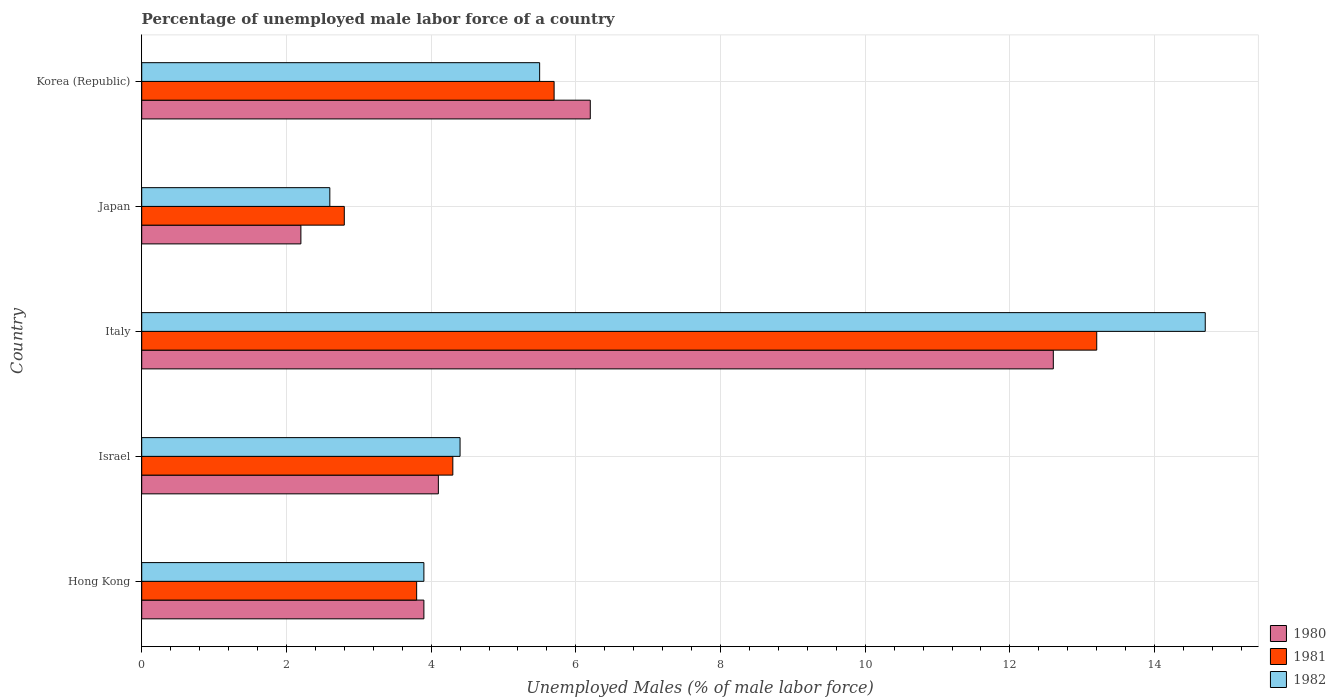How many different coloured bars are there?
Provide a short and direct response. 3. How many groups of bars are there?
Ensure brevity in your answer.  5. How many bars are there on the 3rd tick from the top?
Your answer should be very brief. 3. In how many cases, is the number of bars for a given country not equal to the number of legend labels?
Keep it short and to the point. 0. What is the percentage of unemployed male labor force in 1982 in Japan?
Your answer should be very brief. 2.6. Across all countries, what is the maximum percentage of unemployed male labor force in 1981?
Your answer should be very brief. 13.2. Across all countries, what is the minimum percentage of unemployed male labor force in 1980?
Make the answer very short. 2.2. In which country was the percentage of unemployed male labor force in 1980 maximum?
Ensure brevity in your answer.  Italy. What is the total percentage of unemployed male labor force in 1981 in the graph?
Offer a very short reply. 29.8. What is the difference between the percentage of unemployed male labor force in 1982 in Hong Kong and that in Korea (Republic)?
Keep it short and to the point. -1.6. What is the difference between the percentage of unemployed male labor force in 1981 in Israel and the percentage of unemployed male labor force in 1982 in Hong Kong?
Your response must be concise. 0.4. What is the average percentage of unemployed male labor force in 1982 per country?
Provide a short and direct response. 6.22. What is the difference between the percentage of unemployed male labor force in 1980 and percentage of unemployed male labor force in 1982 in Korea (Republic)?
Make the answer very short. 0.7. In how many countries, is the percentage of unemployed male labor force in 1982 greater than 8 %?
Make the answer very short. 1. What is the ratio of the percentage of unemployed male labor force in 1982 in Japan to that in Korea (Republic)?
Provide a succinct answer. 0.47. Is the percentage of unemployed male labor force in 1980 in Israel less than that in Korea (Republic)?
Offer a very short reply. Yes. What is the difference between the highest and the second highest percentage of unemployed male labor force in 1981?
Provide a short and direct response. 7.5. What is the difference between the highest and the lowest percentage of unemployed male labor force in 1980?
Give a very brief answer. 10.4. In how many countries, is the percentage of unemployed male labor force in 1981 greater than the average percentage of unemployed male labor force in 1981 taken over all countries?
Offer a terse response. 1. What does the 1st bar from the top in Hong Kong represents?
Provide a short and direct response. 1982. Is it the case that in every country, the sum of the percentage of unemployed male labor force in 1982 and percentage of unemployed male labor force in 1980 is greater than the percentage of unemployed male labor force in 1981?
Offer a very short reply. Yes. How many bars are there?
Provide a succinct answer. 15. Are all the bars in the graph horizontal?
Offer a terse response. Yes. How many countries are there in the graph?
Your response must be concise. 5. What is the difference between two consecutive major ticks on the X-axis?
Your response must be concise. 2. Are the values on the major ticks of X-axis written in scientific E-notation?
Provide a short and direct response. No. Does the graph contain any zero values?
Give a very brief answer. No. Does the graph contain grids?
Provide a short and direct response. Yes. How are the legend labels stacked?
Your answer should be very brief. Vertical. What is the title of the graph?
Your answer should be very brief. Percentage of unemployed male labor force of a country. Does "1993" appear as one of the legend labels in the graph?
Make the answer very short. No. What is the label or title of the X-axis?
Your answer should be very brief. Unemployed Males (% of male labor force). What is the label or title of the Y-axis?
Your answer should be very brief. Country. What is the Unemployed Males (% of male labor force) in 1980 in Hong Kong?
Offer a terse response. 3.9. What is the Unemployed Males (% of male labor force) of 1981 in Hong Kong?
Your response must be concise. 3.8. What is the Unemployed Males (% of male labor force) in 1982 in Hong Kong?
Ensure brevity in your answer.  3.9. What is the Unemployed Males (% of male labor force) in 1980 in Israel?
Your answer should be compact. 4.1. What is the Unemployed Males (% of male labor force) in 1981 in Israel?
Offer a terse response. 4.3. What is the Unemployed Males (% of male labor force) in 1982 in Israel?
Offer a terse response. 4.4. What is the Unemployed Males (% of male labor force) of 1980 in Italy?
Your response must be concise. 12.6. What is the Unemployed Males (% of male labor force) in 1981 in Italy?
Your answer should be compact. 13.2. What is the Unemployed Males (% of male labor force) in 1982 in Italy?
Your answer should be very brief. 14.7. What is the Unemployed Males (% of male labor force) in 1980 in Japan?
Make the answer very short. 2.2. What is the Unemployed Males (% of male labor force) of 1981 in Japan?
Offer a very short reply. 2.8. What is the Unemployed Males (% of male labor force) of 1982 in Japan?
Offer a very short reply. 2.6. What is the Unemployed Males (% of male labor force) in 1980 in Korea (Republic)?
Your answer should be compact. 6.2. What is the Unemployed Males (% of male labor force) of 1981 in Korea (Republic)?
Your answer should be very brief. 5.7. Across all countries, what is the maximum Unemployed Males (% of male labor force) of 1980?
Offer a very short reply. 12.6. Across all countries, what is the maximum Unemployed Males (% of male labor force) in 1981?
Keep it short and to the point. 13.2. Across all countries, what is the maximum Unemployed Males (% of male labor force) of 1982?
Provide a short and direct response. 14.7. Across all countries, what is the minimum Unemployed Males (% of male labor force) of 1980?
Your answer should be very brief. 2.2. Across all countries, what is the minimum Unemployed Males (% of male labor force) in 1981?
Offer a terse response. 2.8. Across all countries, what is the minimum Unemployed Males (% of male labor force) of 1982?
Ensure brevity in your answer.  2.6. What is the total Unemployed Males (% of male labor force) in 1981 in the graph?
Offer a very short reply. 29.8. What is the total Unemployed Males (% of male labor force) in 1982 in the graph?
Your answer should be very brief. 31.1. What is the difference between the Unemployed Males (% of male labor force) of 1981 in Hong Kong and that in Italy?
Give a very brief answer. -9.4. What is the difference between the Unemployed Males (% of male labor force) in 1982 in Hong Kong and that in Italy?
Give a very brief answer. -10.8. What is the difference between the Unemployed Males (% of male labor force) of 1981 in Hong Kong and that in Japan?
Your response must be concise. 1. What is the difference between the Unemployed Males (% of male labor force) in 1982 in Hong Kong and that in Japan?
Ensure brevity in your answer.  1.3. What is the difference between the Unemployed Males (% of male labor force) of 1982 in Israel and that in Italy?
Keep it short and to the point. -10.3. What is the difference between the Unemployed Males (% of male labor force) of 1982 in Israel and that in Japan?
Offer a terse response. 1.8. What is the difference between the Unemployed Males (% of male labor force) in 1981 in Israel and that in Korea (Republic)?
Offer a terse response. -1.4. What is the difference between the Unemployed Males (% of male labor force) in 1982 in Israel and that in Korea (Republic)?
Keep it short and to the point. -1.1. What is the difference between the Unemployed Males (% of male labor force) of 1980 in Italy and that in Japan?
Provide a short and direct response. 10.4. What is the difference between the Unemployed Males (% of male labor force) in 1981 in Italy and that in Japan?
Ensure brevity in your answer.  10.4. What is the difference between the Unemployed Males (% of male labor force) in 1980 in Italy and that in Korea (Republic)?
Provide a succinct answer. 6.4. What is the difference between the Unemployed Males (% of male labor force) in 1982 in Italy and that in Korea (Republic)?
Ensure brevity in your answer.  9.2. What is the difference between the Unemployed Males (% of male labor force) in 1982 in Japan and that in Korea (Republic)?
Offer a terse response. -2.9. What is the difference between the Unemployed Males (% of male labor force) of 1980 in Hong Kong and the Unemployed Males (% of male labor force) of 1981 in Italy?
Provide a short and direct response. -9.3. What is the difference between the Unemployed Males (% of male labor force) in 1980 in Hong Kong and the Unemployed Males (% of male labor force) in 1981 in Japan?
Make the answer very short. 1.1. What is the difference between the Unemployed Males (% of male labor force) of 1981 in Hong Kong and the Unemployed Males (% of male labor force) of 1982 in Japan?
Provide a short and direct response. 1.2. What is the difference between the Unemployed Males (% of male labor force) in 1980 in Hong Kong and the Unemployed Males (% of male labor force) in 1981 in Korea (Republic)?
Ensure brevity in your answer.  -1.8. What is the difference between the Unemployed Males (% of male labor force) of 1980 in Hong Kong and the Unemployed Males (% of male labor force) of 1982 in Korea (Republic)?
Keep it short and to the point. -1.6. What is the difference between the Unemployed Males (% of male labor force) in 1980 in Israel and the Unemployed Males (% of male labor force) in 1981 in Italy?
Provide a short and direct response. -9.1. What is the difference between the Unemployed Males (% of male labor force) in 1980 in Israel and the Unemployed Males (% of male labor force) in 1982 in Italy?
Your answer should be compact. -10.6. What is the difference between the Unemployed Males (% of male labor force) in 1981 in Israel and the Unemployed Males (% of male labor force) in 1982 in Korea (Republic)?
Give a very brief answer. -1.2. What is the difference between the Unemployed Males (% of male labor force) in 1980 in Italy and the Unemployed Males (% of male labor force) in 1981 in Japan?
Provide a short and direct response. 9.8. What is the difference between the Unemployed Males (% of male labor force) in 1980 in Italy and the Unemployed Males (% of male labor force) in 1982 in Japan?
Your answer should be very brief. 10. What is the difference between the Unemployed Males (% of male labor force) in 1980 in Italy and the Unemployed Males (% of male labor force) in 1981 in Korea (Republic)?
Make the answer very short. 6.9. What is the difference between the Unemployed Males (% of male labor force) of 1980 in Japan and the Unemployed Males (% of male labor force) of 1982 in Korea (Republic)?
Your answer should be compact. -3.3. What is the average Unemployed Males (% of male labor force) in 1981 per country?
Provide a succinct answer. 5.96. What is the average Unemployed Males (% of male labor force) of 1982 per country?
Provide a short and direct response. 6.22. What is the difference between the Unemployed Males (% of male labor force) in 1980 and Unemployed Males (% of male labor force) in 1982 in Hong Kong?
Make the answer very short. 0. What is the difference between the Unemployed Males (% of male labor force) of 1981 and Unemployed Males (% of male labor force) of 1982 in Hong Kong?
Give a very brief answer. -0.1. What is the difference between the Unemployed Males (% of male labor force) in 1980 and Unemployed Males (% of male labor force) in 1982 in Israel?
Make the answer very short. -0.3. What is the difference between the Unemployed Males (% of male labor force) of 1980 and Unemployed Males (% of male labor force) of 1982 in Italy?
Give a very brief answer. -2.1. What is the difference between the Unemployed Males (% of male labor force) of 1981 and Unemployed Males (% of male labor force) of 1982 in Italy?
Keep it short and to the point. -1.5. What is the difference between the Unemployed Males (% of male labor force) of 1980 and Unemployed Males (% of male labor force) of 1982 in Japan?
Keep it short and to the point. -0.4. What is the difference between the Unemployed Males (% of male labor force) of 1981 and Unemployed Males (% of male labor force) of 1982 in Japan?
Keep it short and to the point. 0.2. What is the difference between the Unemployed Males (% of male labor force) of 1980 and Unemployed Males (% of male labor force) of 1982 in Korea (Republic)?
Your response must be concise. 0.7. What is the ratio of the Unemployed Males (% of male labor force) in 1980 in Hong Kong to that in Israel?
Offer a very short reply. 0.95. What is the ratio of the Unemployed Males (% of male labor force) in 1981 in Hong Kong to that in Israel?
Provide a succinct answer. 0.88. What is the ratio of the Unemployed Males (% of male labor force) of 1982 in Hong Kong to that in Israel?
Give a very brief answer. 0.89. What is the ratio of the Unemployed Males (% of male labor force) in 1980 in Hong Kong to that in Italy?
Keep it short and to the point. 0.31. What is the ratio of the Unemployed Males (% of male labor force) in 1981 in Hong Kong to that in Italy?
Your answer should be very brief. 0.29. What is the ratio of the Unemployed Males (% of male labor force) in 1982 in Hong Kong to that in Italy?
Your response must be concise. 0.27. What is the ratio of the Unemployed Males (% of male labor force) in 1980 in Hong Kong to that in Japan?
Provide a short and direct response. 1.77. What is the ratio of the Unemployed Males (% of male labor force) of 1981 in Hong Kong to that in Japan?
Your answer should be very brief. 1.36. What is the ratio of the Unemployed Males (% of male labor force) of 1982 in Hong Kong to that in Japan?
Your answer should be compact. 1.5. What is the ratio of the Unemployed Males (% of male labor force) of 1980 in Hong Kong to that in Korea (Republic)?
Provide a short and direct response. 0.63. What is the ratio of the Unemployed Males (% of male labor force) of 1981 in Hong Kong to that in Korea (Republic)?
Offer a very short reply. 0.67. What is the ratio of the Unemployed Males (% of male labor force) of 1982 in Hong Kong to that in Korea (Republic)?
Your answer should be compact. 0.71. What is the ratio of the Unemployed Males (% of male labor force) of 1980 in Israel to that in Italy?
Your answer should be very brief. 0.33. What is the ratio of the Unemployed Males (% of male labor force) of 1981 in Israel to that in Italy?
Give a very brief answer. 0.33. What is the ratio of the Unemployed Males (% of male labor force) of 1982 in Israel to that in Italy?
Keep it short and to the point. 0.3. What is the ratio of the Unemployed Males (% of male labor force) of 1980 in Israel to that in Japan?
Offer a very short reply. 1.86. What is the ratio of the Unemployed Males (% of male labor force) in 1981 in Israel to that in Japan?
Ensure brevity in your answer.  1.54. What is the ratio of the Unemployed Males (% of male labor force) in 1982 in Israel to that in Japan?
Keep it short and to the point. 1.69. What is the ratio of the Unemployed Males (% of male labor force) of 1980 in Israel to that in Korea (Republic)?
Make the answer very short. 0.66. What is the ratio of the Unemployed Males (% of male labor force) of 1981 in Israel to that in Korea (Republic)?
Give a very brief answer. 0.75. What is the ratio of the Unemployed Males (% of male labor force) of 1982 in Israel to that in Korea (Republic)?
Your answer should be very brief. 0.8. What is the ratio of the Unemployed Males (% of male labor force) of 1980 in Italy to that in Japan?
Make the answer very short. 5.73. What is the ratio of the Unemployed Males (% of male labor force) of 1981 in Italy to that in Japan?
Give a very brief answer. 4.71. What is the ratio of the Unemployed Males (% of male labor force) of 1982 in Italy to that in Japan?
Provide a short and direct response. 5.65. What is the ratio of the Unemployed Males (% of male labor force) in 1980 in Italy to that in Korea (Republic)?
Give a very brief answer. 2.03. What is the ratio of the Unemployed Males (% of male labor force) in 1981 in Italy to that in Korea (Republic)?
Your answer should be compact. 2.32. What is the ratio of the Unemployed Males (% of male labor force) in 1982 in Italy to that in Korea (Republic)?
Provide a succinct answer. 2.67. What is the ratio of the Unemployed Males (% of male labor force) of 1980 in Japan to that in Korea (Republic)?
Give a very brief answer. 0.35. What is the ratio of the Unemployed Males (% of male labor force) in 1981 in Japan to that in Korea (Republic)?
Keep it short and to the point. 0.49. What is the ratio of the Unemployed Males (% of male labor force) of 1982 in Japan to that in Korea (Republic)?
Your answer should be compact. 0.47. What is the difference between the highest and the second highest Unemployed Males (% of male labor force) in 1980?
Offer a terse response. 6.4. What is the difference between the highest and the lowest Unemployed Males (% of male labor force) of 1980?
Your answer should be compact. 10.4. 